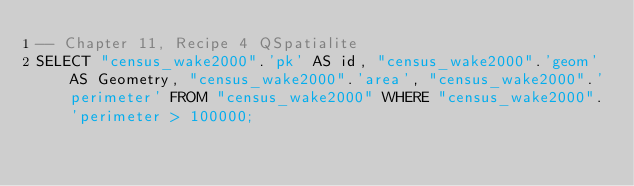Convert code to text. <code><loc_0><loc_0><loc_500><loc_500><_SQL_>-- Chapter 11, Recipe 4 QSpatialite
SELECT "census_wake2000".'pk' AS id, "census_wake2000".'geom' AS Geometry, "census_wake2000".'area', "census_wake2000".'perimeter' FROM "census_wake2000" WHERE "census_wake2000".'perimeter > 100000;
</code> 